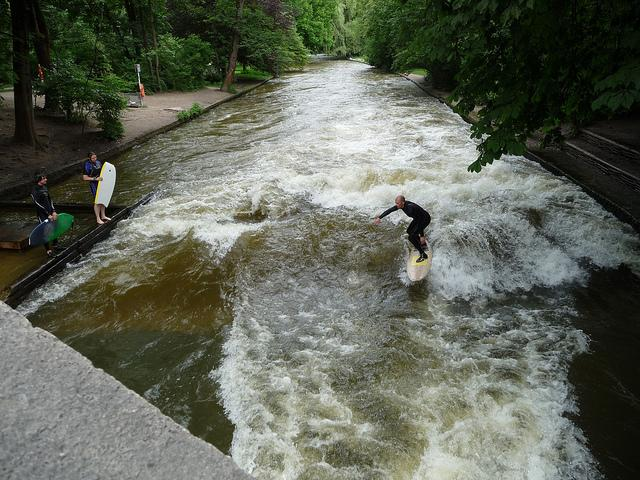Tidal bores surfing can be played on which water?

Choices:
A) ocean
B) pond
C) river
D) sea river 